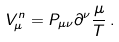Convert formula to latex. <formula><loc_0><loc_0><loc_500><loc_500>V _ { \mu } ^ { n } = P _ { \mu \nu } \partial ^ { \nu } \frac { \mu } { T } \, .</formula> 